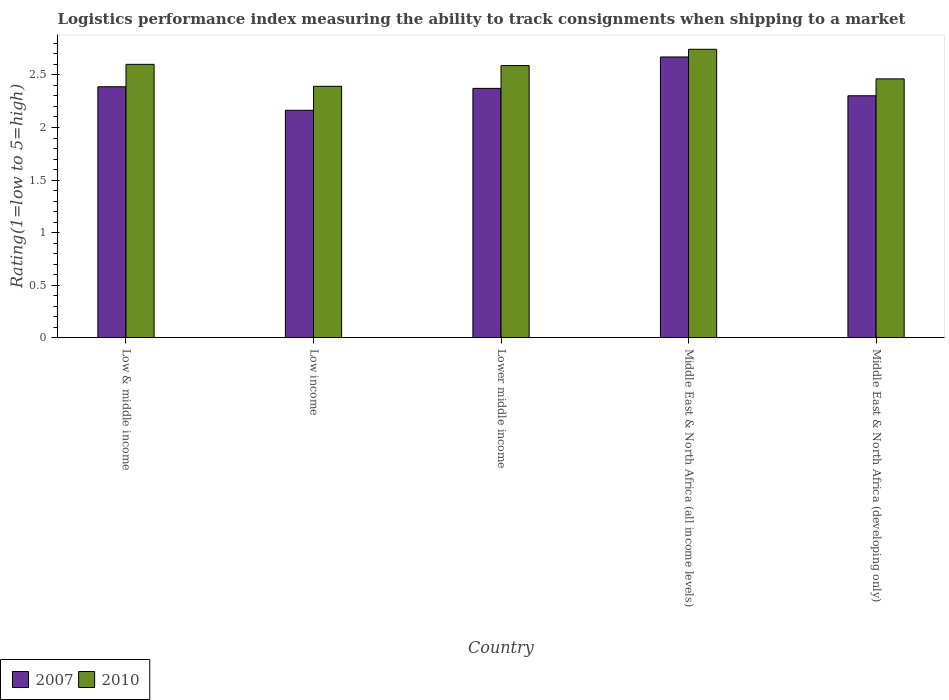How many different coloured bars are there?
Ensure brevity in your answer.  2. How many groups of bars are there?
Your response must be concise. 5. Are the number of bars on each tick of the X-axis equal?
Offer a very short reply. Yes. What is the label of the 3rd group of bars from the left?
Ensure brevity in your answer.  Lower middle income. What is the Logistic performance index in 2007 in Lower middle income?
Offer a very short reply. 2.37. Across all countries, what is the maximum Logistic performance index in 2010?
Your answer should be very brief. 2.74. Across all countries, what is the minimum Logistic performance index in 2007?
Your answer should be compact. 2.16. In which country was the Logistic performance index in 2007 maximum?
Keep it short and to the point. Middle East & North Africa (all income levels). What is the total Logistic performance index in 2010 in the graph?
Provide a short and direct response. 12.79. What is the difference between the Logistic performance index in 2007 in Low income and that in Middle East & North Africa (developing only)?
Provide a succinct answer. -0.14. What is the difference between the Logistic performance index in 2010 in Low & middle income and the Logistic performance index in 2007 in Middle East & North Africa (all income levels)?
Keep it short and to the point. -0.07. What is the average Logistic performance index in 2007 per country?
Provide a short and direct response. 2.38. What is the difference between the Logistic performance index of/in 2010 and Logistic performance index of/in 2007 in Middle East & North Africa (all income levels)?
Your answer should be very brief. 0.07. What is the ratio of the Logistic performance index in 2010 in Low & middle income to that in Lower middle income?
Provide a short and direct response. 1. Is the Logistic performance index in 2010 in Lower middle income less than that in Middle East & North Africa (all income levels)?
Keep it short and to the point. Yes. Is the difference between the Logistic performance index in 2010 in Low income and Middle East & North Africa (developing only) greater than the difference between the Logistic performance index in 2007 in Low income and Middle East & North Africa (developing only)?
Make the answer very short. Yes. What is the difference between the highest and the second highest Logistic performance index in 2010?
Your response must be concise. 0.14. What is the difference between the highest and the lowest Logistic performance index in 2010?
Your answer should be very brief. 0.35. In how many countries, is the Logistic performance index in 2010 greater than the average Logistic performance index in 2010 taken over all countries?
Your answer should be compact. 3. Is the sum of the Logistic performance index in 2010 in Low income and Middle East & North Africa (all income levels) greater than the maximum Logistic performance index in 2007 across all countries?
Offer a terse response. Yes. What does the 1st bar from the left in Middle East & North Africa (all income levels) represents?
Your answer should be very brief. 2007. How many countries are there in the graph?
Offer a terse response. 5. Are the values on the major ticks of Y-axis written in scientific E-notation?
Offer a terse response. No. Does the graph contain any zero values?
Offer a very short reply. No. Does the graph contain grids?
Ensure brevity in your answer.  No. How many legend labels are there?
Give a very brief answer. 2. What is the title of the graph?
Your response must be concise. Logistics performance index measuring the ability to track consignments when shipping to a market. What is the label or title of the X-axis?
Your response must be concise. Country. What is the label or title of the Y-axis?
Provide a short and direct response. Rating(1=low to 5=high). What is the Rating(1=low to 5=high) in 2007 in Low & middle income?
Make the answer very short. 2.39. What is the Rating(1=low to 5=high) in 2010 in Low & middle income?
Offer a very short reply. 2.6. What is the Rating(1=low to 5=high) of 2007 in Low income?
Provide a short and direct response. 2.16. What is the Rating(1=low to 5=high) of 2010 in Low income?
Your answer should be compact. 2.39. What is the Rating(1=low to 5=high) of 2007 in Lower middle income?
Keep it short and to the point. 2.37. What is the Rating(1=low to 5=high) of 2010 in Lower middle income?
Provide a short and direct response. 2.59. What is the Rating(1=low to 5=high) in 2007 in Middle East & North Africa (all income levels)?
Ensure brevity in your answer.  2.67. What is the Rating(1=low to 5=high) in 2010 in Middle East & North Africa (all income levels)?
Your response must be concise. 2.74. What is the Rating(1=low to 5=high) in 2007 in Middle East & North Africa (developing only)?
Ensure brevity in your answer.  2.3. What is the Rating(1=low to 5=high) in 2010 in Middle East & North Africa (developing only)?
Your answer should be compact. 2.46. Across all countries, what is the maximum Rating(1=low to 5=high) in 2007?
Your response must be concise. 2.67. Across all countries, what is the maximum Rating(1=low to 5=high) of 2010?
Ensure brevity in your answer.  2.74. Across all countries, what is the minimum Rating(1=low to 5=high) in 2007?
Keep it short and to the point. 2.16. Across all countries, what is the minimum Rating(1=low to 5=high) in 2010?
Your answer should be compact. 2.39. What is the total Rating(1=low to 5=high) in 2007 in the graph?
Offer a very short reply. 11.9. What is the total Rating(1=low to 5=high) of 2010 in the graph?
Offer a very short reply. 12.79. What is the difference between the Rating(1=low to 5=high) of 2007 in Low & middle income and that in Low income?
Keep it short and to the point. 0.22. What is the difference between the Rating(1=low to 5=high) of 2010 in Low & middle income and that in Low income?
Make the answer very short. 0.21. What is the difference between the Rating(1=low to 5=high) of 2007 in Low & middle income and that in Lower middle income?
Your answer should be compact. 0.02. What is the difference between the Rating(1=low to 5=high) of 2010 in Low & middle income and that in Lower middle income?
Your answer should be very brief. 0.01. What is the difference between the Rating(1=low to 5=high) of 2007 in Low & middle income and that in Middle East & North Africa (all income levels)?
Offer a terse response. -0.28. What is the difference between the Rating(1=low to 5=high) in 2010 in Low & middle income and that in Middle East & North Africa (all income levels)?
Offer a very short reply. -0.14. What is the difference between the Rating(1=low to 5=high) in 2007 in Low & middle income and that in Middle East & North Africa (developing only)?
Provide a succinct answer. 0.09. What is the difference between the Rating(1=low to 5=high) in 2010 in Low & middle income and that in Middle East & North Africa (developing only)?
Make the answer very short. 0.14. What is the difference between the Rating(1=low to 5=high) of 2007 in Low income and that in Lower middle income?
Keep it short and to the point. -0.21. What is the difference between the Rating(1=low to 5=high) in 2010 in Low income and that in Lower middle income?
Offer a very short reply. -0.2. What is the difference between the Rating(1=low to 5=high) of 2007 in Low income and that in Middle East & North Africa (all income levels)?
Ensure brevity in your answer.  -0.51. What is the difference between the Rating(1=low to 5=high) in 2010 in Low income and that in Middle East & North Africa (all income levels)?
Provide a short and direct response. -0.35. What is the difference between the Rating(1=low to 5=high) in 2007 in Low income and that in Middle East & North Africa (developing only)?
Keep it short and to the point. -0.14. What is the difference between the Rating(1=low to 5=high) in 2010 in Low income and that in Middle East & North Africa (developing only)?
Your answer should be compact. -0.07. What is the difference between the Rating(1=low to 5=high) in 2007 in Lower middle income and that in Middle East & North Africa (all income levels)?
Make the answer very short. -0.3. What is the difference between the Rating(1=low to 5=high) in 2010 in Lower middle income and that in Middle East & North Africa (all income levels)?
Offer a very short reply. -0.15. What is the difference between the Rating(1=low to 5=high) in 2007 in Lower middle income and that in Middle East & North Africa (developing only)?
Offer a terse response. 0.07. What is the difference between the Rating(1=low to 5=high) of 2010 in Lower middle income and that in Middle East & North Africa (developing only)?
Your answer should be very brief. 0.13. What is the difference between the Rating(1=low to 5=high) in 2007 in Middle East & North Africa (all income levels) and that in Middle East & North Africa (developing only)?
Keep it short and to the point. 0.37. What is the difference between the Rating(1=low to 5=high) in 2010 in Middle East & North Africa (all income levels) and that in Middle East & North Africa (developing only)?
Provide a succinct answer. 0.28. What is the difference between the Rating(1=low to 5=high) of 2007 in Low & middle income and the Rating(1=low to 5=high) of 2010 in Low income?
Offer a terse response. -0. What is the difference between the Rating(1=low to 5=high) in 2007 in Low & middle income and the Rating(1=low to 5=high) in 2010 in Lower middle income?
Give a very brief answer. -0.2. What is the difference between the Rating(1=low to 5=high) of 2007 in Low & middle income and the Rating(1=low to 5=high) of 2010 in Middle East & North Africa (all income levels)?
Keep it short and to the point. -0.36. What is the difference between the Rating(1=low to 5=high) of 2007 in Low & middle income and the Rating(1=low to 5=high) of 2010 in Middle East & North Africa (developing only)?
Your response must be concise. -0.08. What is the difference between the Rating(1=low to 5=high) in 2007 in Low income and the Rating(1=low to 5=high) in 2010 in Lower middle income?
Provide a succinct answer. -0.43. What is the difference between the Rating(1=low to 5=high) in 2007 in Low income and the Rating(1=low to 5=high) in 2010 in Middle East & North Africa (all income levels)?
Give a very brief answer. -0.58. What is the difference between the Rating(1=low to 5=high) of 2007 in Low income and the Rating(1=low to 5=high) of 2010 in Middle East & North Africa (developing only)?
Ensure brevity in your answer.  -0.3. What is the difference between the Rating(1=low to 5=high) in 2007 in Lower middle income and the Rating(1=low to 5=high) in 2010 in Middle East & North Africa (all income levels)?
Make the answer very short. -0.37. What is the difference between the Rating(1=low to 5=high) of 2007 in Lower middle income and the Rating(1=low to 5=high) of 2010 in Middle East & North Africa (developing only)?
Offer a very short reply. -0.09. What is the difference between the Rating(1=low to 5=high) in 2007 in Middle East & North Africa (all income levels) and the Rating(1=low to 5=high) in 2010 in Middle East & North Africa (developing only)?
Your response must be concise. 0.21. What is the average Rating(1=low to 5=high) of 2007 per country?
Provide a short and direct response. 2.38. What is the average Rating(1=low to 5=high) in 2010 per country?
Offer a terse response. 2.56. What is the difference between the Rating(1=low to 5=high) in 2007 and Rating(1=low to 5=high) in 2010 in Low & middle income?
Make the answer very short. -0.21. What is the difference between the Rating(1=low to 5=high) in 2007 and Rating(1=low to 5=high) in 2010 in Low income?
Ensure brevity in your answer.  -0.23. What is the difference between the Rating(1=low to 5=high) in 2007 and Rating(1=low to 5=high) in 2010 in Lower middle income?
Your response must be concise. -0.22. What is the difference between the Rating(1=low to 5=high) of 2007 and Rating(1=low to 5=high) of 2010 in Middle East & North Africa (all income levels)?
Provide a short and direct response. -0.07. What is the difference between the Rating(1=low to 5=high) of 2007 and Rating(1=low to 5=high) of 2010 in Middle East & North Africa (developing only)?
Provide a short and direct response. -0.16. What is the ratio of the Rating(1=low to 5=high) of 2007 in Low & middle income to that in Low income?
Offer a terse response. 1.1. What is the ratio of the Rating(1=low to 5=high) of 2010 in Low & middle income to that in Low income?
Provide a succinct answer. 1.09. What is the ratio of the Rating(1=low to 5=high) in 2007 in Low & middle income to that in Lower middle income?
Ensure brevity in your answer.  1.01. What is the ratio of the Rating(1=low to 5=high) of 2010 in Low & middle income to that in Lower middle income?
Offer a very short reply. 1. What is the ratio of the Rating(1=low to 5=high) in 2007 in Low & middle income to that in Middle East & North Africa (all income levels)?
Ensure brevity in your answer.  0.89. What is the ratio of the Rating(1=low to 5=high) of 2010 in Low & middle income to that in Middle East & North Africa (all income levels)?
Provide a short and direct response. 0.95. What is the ratio of the Rating(1=low to 5=high) in 2007 in Low & middle income to that in Middle East & North Africa (developing only)?
Ensure brevity in your answer.  1.04. What is the ratio of the Rating(1=low to 5=high) in 2010 in Low & middle income to that in Middle East & North Africa (developing only)?
Ensure brevity in your answer.  1.06. What is the ratio of the Rating(1=low to 5=high) in 2007 in Low income to that in Lower middle income?
Provide a succinct answer. 0.91. What is the ratio of the Rating(1=low to 5=high) in 2010 in Low income to that in Lower middle income?
Give a very brief answer. 0.92. What is the ratio of the Rating(1=low to 5=high) in 2007 in Low income to that in Middle East & North Africa (all income levels)?
Your answer should be compact. 0.81. What is the ratio of the Rating(1=low to 5=high) in 2010 in Low income to that in Middle East & North Africa (all income levels)?
Offer a very short reply. 0.87. What is the ratio of the Rating(1=low to 5=high) of 2007 in Low income to that in Middle East & North Africa (developing only)?
Your response must be concise. 0.94. What is the ratio of the Rating(1=low to 5=high) of 2010 in Low income to that in Middle East & North Africa (developing only)?
Ensure brevity in your answer.  0.97. What is the ratio of the Rating(1=low to 5=high) in 2007 in Lower middle income to that in Middle East & North Africa (all income levels)?
Your answer should be very brief. 0.89. What is the ratio of the Rating(1=low to 5=high) of 2010 in Lower middle income to that in Middle East & North Africa (all income levels)?
Your response must be concise. 0.94. What is the ratio of the Rating(1=low to 5=high) of 2007 in Lower middle income to that in Middle East & North Africa (developing only)?
Provide a succinct answer. 1.03. What is the ratio of the Rating(1=low to 5=high) in 2010 in Lower middle income to that in Middle East & North Africa (developing only)?
Offer a terse response. 1.05. What is the ratio of the Rating(1=low to 5=high) in 2007 in Middle East & North Africa (all income levels) to that in Middle East & North Africa (developing only)?
Your response must be concise. 1.16. What is the ratio of the Rating(1=low to 5=high) in 2010 in Middle East & North Africa (all income levels) to that in Middle East & North Africa (developing only)?
Provide a succinct answer. 1.11. What is the difference between the highest and the second highest Rating(1=low to 5=high) of 2007?
Your response must be concise. 0.28. What is the difference between the highest and the second highest Rating(1=low to 5=high) in 2010?
Offer a terse response. 0.14. What is the difference between the highest and the lowest Rating(1=low to 5=high) of 2007?
Your answer should be compact. 0.51. What is the difference between the highest and the lowest Rating(1=low to 5=high) in 2010?
Keep it short and to the point. 0.35. 